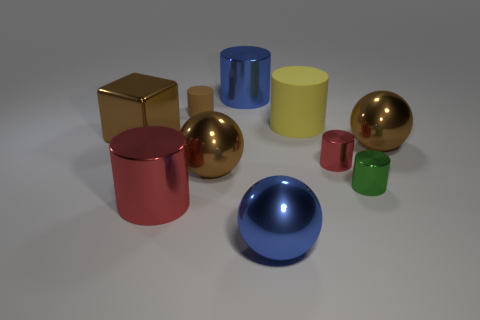Subtract 2 cylinders. How many cylinders are left? 4 Subtract all tiny green cylinders. How many cylinders are left? 5 Subtract all red cylinders. How many cylinders are left? 4 Subtract all gray cylinders. Subtract all green cubes. How many cylinders are left? 6 Subtract all cylinders. How many objects are left? 4 Add 3 large blue shiny objects. How many large blue shiny objects exist? 5 Subtract 1 green cylinders. How many objects are left? 9 Subtract all tiny metallic objects. Subtract all brown metal cylinders. How many objects are left? 8 Add 5 large brown cubes. How many large brown cubes are left? 6 